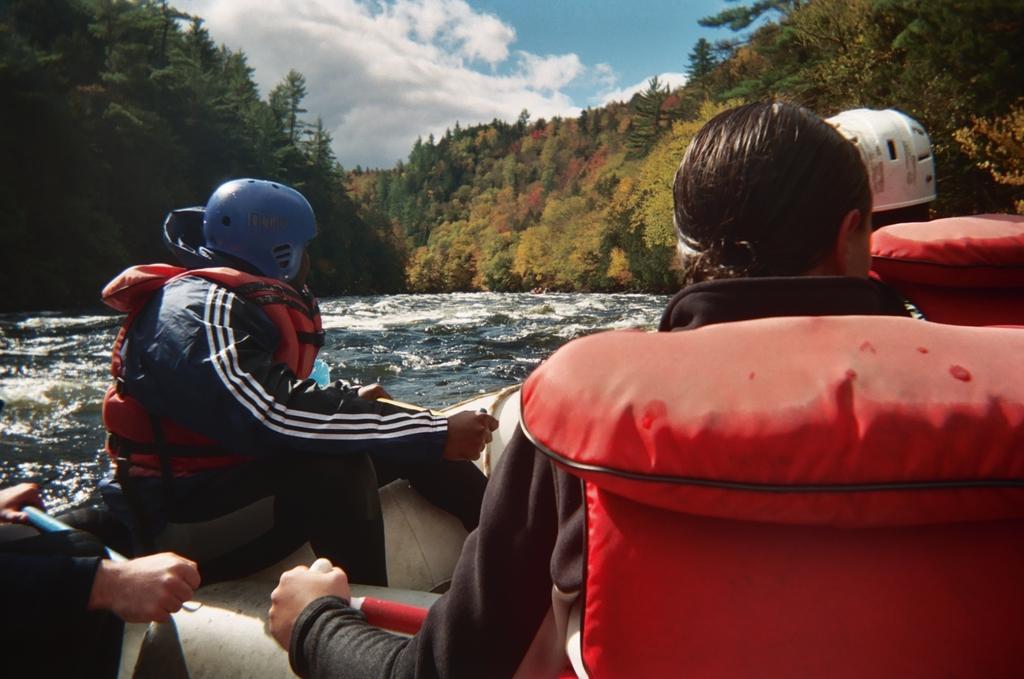Could you give a brief overview of what you see in this image? In this image we can see people sitting on the boat. In the background there are sky with clouds, trees and water. 